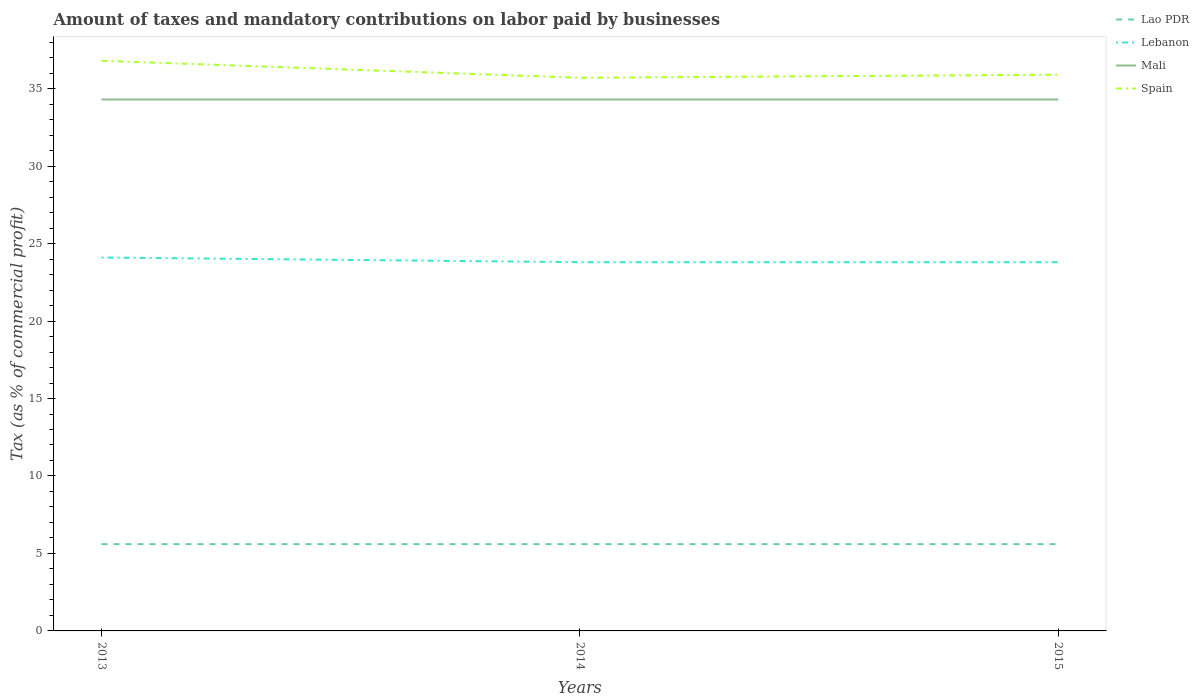How many different coloured lines are there?
Your answer should be compact. 4. Does the line corresponding to Spain intersect with the line corresponding to Lebanon?
Provide a short and direct response. No. Is the number of lines equal to the number of legend labels?
Give a very brief answer. Yes. Across all years, what is the maximum percentage of taxes paid by businesses in Spain?
Offer a very short reply. 35.7. What is the total percentage of taxes paid by businesses in Spain in the graph?
Offer a very short reply. 1.1. What is the difference between the highest and the second highest percentage of taxes paid by businesses in Mali?
Give a very brief answer. 0. What is the difference between the highest and the lowest percentage of taxes paid by businesses in Lao PDR?
Your answer should be very brief. 3. How many lines are there?
Keep it short and to the point. 4. How many years are there in the graph?
Your answer should be compact. 3. Does the graph contain grids?
Your response must be concise. No. Where does the legend appear in the graph?
Your response must be concise. Top right. What is the title of the graph?
Provide a short and direct response. Amount of taxes and mandatory contributions on labor paid by businesses. Does "Paraguay" appear as one of the legend labels in the graph?
Provide a succinct answer. No. What is the label or title of the Y-axis?
Offer a terse response. Tax (as % of commercial profit). What is the Tax (as % of commercial profit) of Lao PDR in 2013?
Ensure brevity in your answer.  5.6. What is the Tax (as % of commercial profit) of Lebanon in 2013?
Your answer should be very brief. 24.1. What is the Tax (as % of commercial profit) of Mali in 2013?
Make the answer very short. 34.3. What is the Tax (as % of commercial profit) of Spain in 2013?
Your answer should be very brief. 36.8. What is the Tax (as % of commercial profit) of Lebanon in 2014?
Provide a succinct answer. 23.8. What is the Tax (as % of commercial profit) in Mali in 2014?
Offer a terse response. 34.3. What is the Tax (as % of commercial profit) in Spain in 2014?
Your response must be concise. 35.7. What is the Tax (as % of commercial profit) in Lebanon in 2015?
Make the answer very short. 23.8. What is the Tax (as % of commercial profit) of Mali in 2015?
Your answer should be very brief. 34.3. What is the Tax (as % of commercial profit) of Spain in 2015?
Provide a short and direct response. 35.9. Across all years, what is the maximum Tax (as % of commercial profit) in Lebanon?
Provide a succinct answer. 24.1. Across all years, what is the maximum Tax (as % of commercial profit) in Mali?
Give a very brief answer. 34.3. Across all years, what is the maximum Tax (as % of commercial profit) of Spain?
Offer a terse response. 36.8. Across all years, what is the minimum Tax (as % of commercial profit) in Lao PDR?
Your answer should be compact. 5.6. Across all years, what is the minimum Tax (as % of commercial profit) of Lebanon?
Offer a very short reply. 23.8. Across all years, what is the minimum Tax (as % of commercial profit) in Mali?
Your answer should be compact. 34.3. Across all years, what is the minimum Tax (as % of commercial profit) of Spain?
Provide a succinct answer. 35.7. What is the total Tax (as % of commercial profit) of Lao PDR in the graph?
Your response must be concise. 16.8. What is the total Tax (as % of commercial profit) in Lebanon in the graph?
Provide a succinct answer. 71.7. What is the total Tax (as % of commercial profit) in Mali in the graph?
Provide a short and direct response. 102.9. What is the total Tax (as % of commercial profit) of Spain in the graph?
Your response must be concise. 108.4. What is the difference between the Tax (as % of commercial profit) in Mali in 2013 and that in 2014?
Offer a very short reply. 0. What is the difference between the Tax (as % of commercial profit) of Lebanon in 2013 and that in 2015?
Ensure brevity in your answer.  0.3. What is the difference between the Tax (as % of commercial profit) of Mali in 2013 and that in 2015?
Keep it short and to the point. 0. What is the difference between the Tax (as % of commercial profit) of Spain in 2013 and that in 2015?
Ensure brevity in your answer.  0.9. What is the difference between the Tax (as % of commercial profit) in Lebanon in 2014 and that in 2015?
Ensure brevity in your answer.  0. What is the difference between the Tax (as % of commercial profit) of Mali in 2014 and that in 2015?
Your answer should be very brief. 0. What is the difference between the Tax (as % of commercial profit) of Spain in 2014 and that in 2015?
Your response must be concise. -0.2. What is the difference between the Tax (as % of commercial profit) in Lao PDR in 2013 and the Tax (as % of commercial profit) in Lebanon in 2014?
Your answer should be very brief. -18.2. What is the difference between the Tax (as % of commercial profit) of Lao PDR in 2013 and the Tax (as % of commercial profit) of Mali in 2014?
Offer a terse response. -28.7. What is the difference between the Tax (as % of commercial profit) of Lao PDR in 2013 and the Tax (as % of commercial profit) of Spain in 2014?
Ensure brevity in your answer.  -30.1. What is the difference between the Tax (as % of commercial profit) of Lao PDR in 2013 and the Tax (as % of commercial profit) of Lebanon in 2015?
Your response must be concise. -18.2. What is the difference between the Tax (as % of commercial profit) of Lao PDR in 2013 and the Tax (as % of commercial profit) of Mali in 2015?
Make the answer very short. -28.7. What is the difference between the Tax (as % of commercial profit) in Lao PDR in 2013 and the Tax (as % of commercial profit) in Spain in 2015?
Your response must be concise. -30.3. What is the difference between the Tax (as % of commercial profit) in Lebanon in 2013 and the Tax (as % of commercial profit) in Mali in 2015?
Your answer should be compact. -10.2. What is the difference between the Tax (as % of commercial profit) in Lao PDR in 2014 and the Tax (as % of commercial profit) in Lebanon in 2015?
Make the answer very short. -18.2. What is the difference between the Tax (as % of commercial profit) of Lao PDR in 2014 and the Tax (as % of commercial profit) of Mali in 2015?
Your response must be concise. -28.7. What is the difference between the Tax (as % of commercial profit) in Lao PDR in 2014 and the Tax (as % of commercial profit) in Spain in 2015?
Your answer should be very brief. -30.3. What is the difference between the Tax (as % of commercial profit) in Lebanon in 2014 and the Tax (as % of commercial profit) in Mali in 2015?
Ensure brevity in your answer.  -10.5. What is the average Tax (as % of commercial profit) in Lebanon per year?
Keep it short and to the point. 23.9. What is the average Tax (as % of commercial profit) in Mali per year?
Make the answer very short. 34.3. What is the average Tax (as % of commercial profit) in Spain per year?
Give a very brief answer. 36.13. In the year 2013, what is the difference between the Tax (as % of commercial profit) of Lao PDR and Tax (as % of commercial profit) of Lebanon?
Make the answer very short. -18.5. In the year 2013, what is the difference between the Tax (as % of commercial profit) in Lao PDR and Tax (as % of commercial profit) in Mali?
Provide a succinct answer. -28.7. In the year 2013, what is the difference between the Tax (as % of commercial profit) of Lao PDR and Tax (as % of commercial profit) of Spain?
Your response must be concise. -31.2. In the year 2013, what is the difference between the Tax (as % of commercial profit) in Mali and Tax (as % of commercial profit) in Spain?
Your answer should be compact. -2.5. In the year 2014, what is the difference between the Tax (as % of commercial profit) in Lao PDR and Tax (as % of commercial profit) in Lebanon?
Your answer should be compact. -18.2. In the year 2014, what is the difference between the Tax (as % of commercial profit) of Lao PDR and Tax (as % of commercial profit) of Mali?
Your answer should be compact. -28.7. In the year 2014, what is the difference between the Tax (as % of commercial profit) in Lao PDR and Tax (as % of commercial profit) in Spain?
Offer a very short reply. -30.1. In the year 2015, what is the difference between the Tax (as % of commercial profit) in Lao PDR and Tax (as % of commercial profit) in Lebanon?
Your answer should be compact. -18.2. In the year 2015, what is the difference between the Tax (as % of commercial profit) in Lao PDR and Tax (as % of commercial profit) in Mali?
Provide a succinct answer. -28.7. In the year 2015, what is the difference between the Tax (as % of commercial profit) of Lao PDR and Tax (as % of commercial profit) of Spain?
Your answer should be compact. -30.3. In the year 2015, what is the difference between the Tax (as % of commercial profit) in Lebanon and Tax (as % of commercial profit) in Spain?
Keep it short and to the point. -12.1. What is the ratio of the Tax (as % of commercial profit) of Lao PDR in 2013 to that in 2014?
Offer a terse response. 1. What is the ratio of the Tax (as % of commercial profit) in Lebanon in 2013 to that in 2014?
Provide a short and direct response. 1.01. What is the ratio of the Tax (as % of commercial profit) of Spain in 2013 to that in 2014?
Give a very brief answer. 1.03. What is the ratio of the Tax (as % of commercial profit) in Lao PDR in 2013 to that in 2015?
Give a very brief answer. 1. What is the ratio of the Tax (as % of commercial profit) in Lebanon in 2013 to that in 2015?
Keep it short and to the point. 1.01. What is the ratio of the Tax (as % of commercial profit) in Mali in 2013 to that in 2015?
Your answer should be compact. 1. What is the ratio of the Tax (as % of commercial profit) in Spain in 2013 to that in 2015?
Your response must be concise. 1.03. What is the ratio of the Tax (as % of commercial profit) in Mali in 2014 to that in 2015?
Give a very brief answer. 1. What is the difference between the highest and the second highest Tax (as % of commercial profit) of Lao PDR?
Keep it short and to the point. 0. What is the difference between the highest and the second highest Tax (as % of commercial profit) of Spain?
Your answer should be very brief. 0.9. What is the difference between the highest and the lowest Tax (as % of commercial profit) of Mali?
Give a very brief answer. 0. What is the difference between the highest and the lowest Tax (as % of commercial profit) in Spain?
Provide a succinct answer. 1.1. 